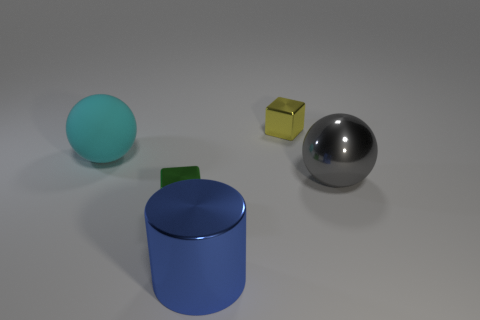Is there a blue object made of the same material as the big cyan ball?
Provide a succinct answer. No. Is the size of the sphere on the left side of the big gray metal ball the same as the metal block that is on the right side of the large blue metallic cylinder?
Offer a very short reply. No. What size is the object on the right side of the tiny yellow block?
Your response must be concise. Large. Are there any metallic spheres that have the same color as the large metallic cylinder?
Your answer should be very brief. No. There is a small object on the left side of the large blue metallic cylinder; are there any cyan matte objects in front of it?
Your answer should be very brief. No. There is a yellow object; is it the same size as the ball that is in front of the cyan rubber sphere?
Give a very brief answer. No. Is there a yellow object that is right of the cube that is in front of the large sphere in front of the cyan matte sphere?
Your response must be concise. Yes. What is the material of the gray thing that is behind the tiny green thing?
Make the answer very short. Metal. Does the green object have the same size as the rubber thing?
Your answer should be very brief. No. The metal thing that is on the right side of the blue cylinder and in front of the tiny yellow object is what color?
Keep it short and to the point. Gray. 